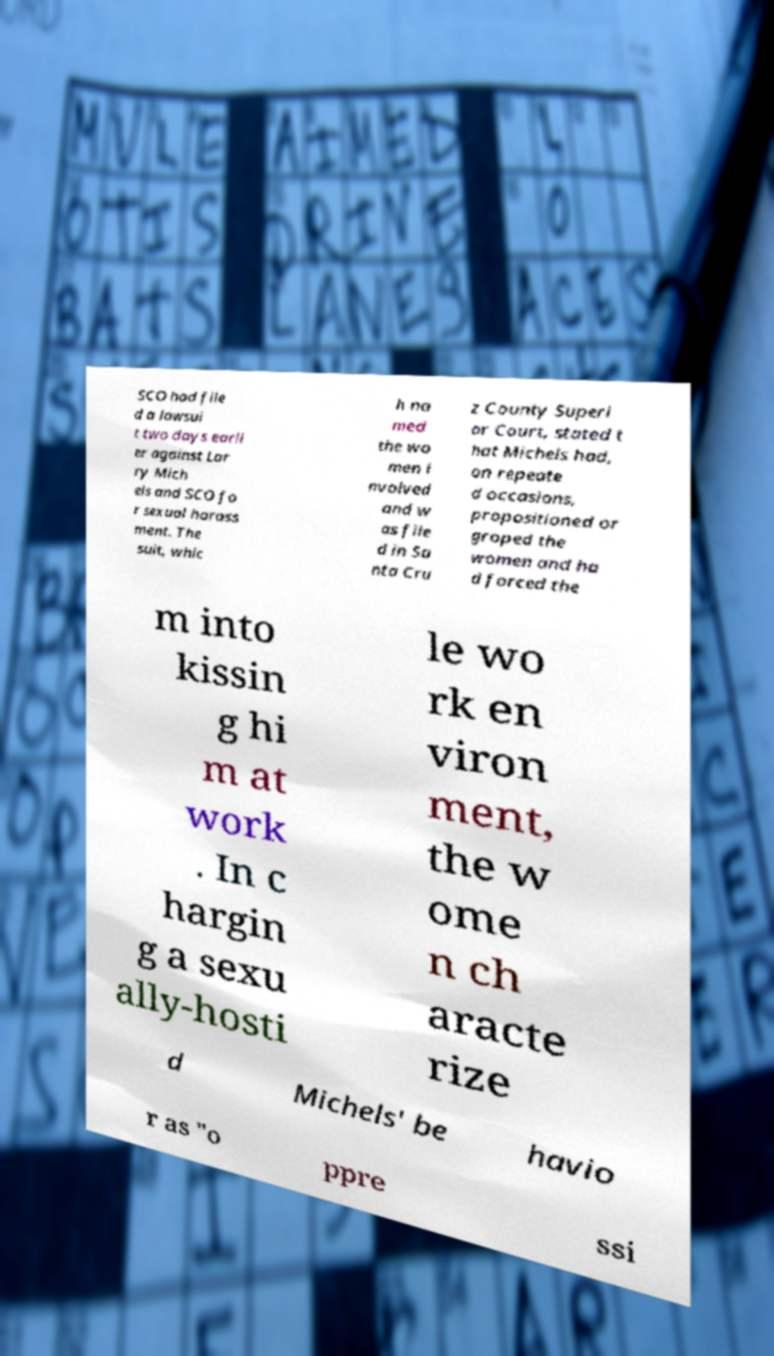Could you assist in decoding the text presented in this image and type it out clearly? SCO had file d a lawsui t two days earli er against Lar ry Mich els and SCO fo r sexual harass ment. The suit, whic h na med the wo men i nvolved and w as file d in Sa nta Cru z County Superi or Court, stated t hat Michels had, on repeate d occasions, propositioned or groped the women and ha d forced the m into kissin g hi m at work . In c hargin g a sexu ally-hosti le wo rk en viron ment, the w ome n ch aracte rize d Michels' be havio r as "o ppre ssi 